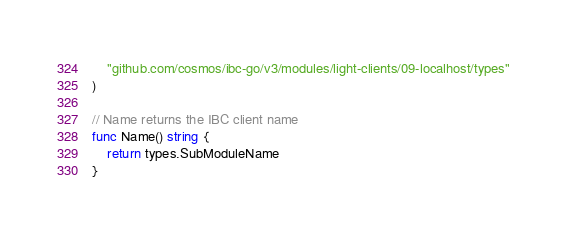<code> <loc_0><loc_0><loc_500><loc_500><_Go_>	"github.com/cosmos/ibc-go/v3/modules/light-clients/09-localhost/types"
)

// Name returns the IBC client name
func Name() string {
	return types.SubModuleName
}
</code> 